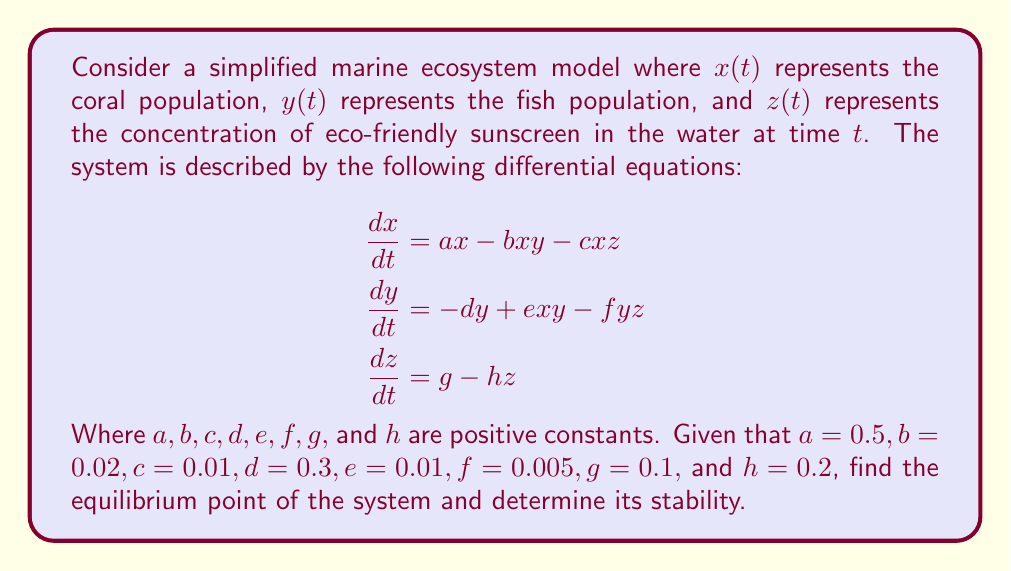Help me with this question. To solve this problem, we'll follow these steps:

1) Find the equilibrium point by setting all derivatives to zero and solving the resulting system of equations.

2) Compute the Jacobian matrix at the equilibrium point.

3) Evaluate the eigenvalues of the Jacobian to determine stability.

Step 1: Finding the equilibrium point

Set all derivatives to zero:

$$\begin{aligned}
0 &= 0.5x - 0.02xy - 0.01xz \\
0 &= -0.3y + 0.01xy - 0.005yz \\
0 &= 0.1 - 0.2z
\end{aligned}$$

From the third equation:
$z = 0.5$

Substituting this into the first two equations:

$$\begin{aligned}
0 &= 0.5x - 0.02xy - 0.005x \\
0 &= -0.3y + 0.01xy - 0.0025y
\end{aligned}$$

Simplifying:

$$\begin{aligned}
0 &= 0.495x - 0.02xy \\
0 &= y(0.01x - 0.3025)
\end{aligned}$$

From the second equation, either $y = 0$ or $x = 30.25$. If $y = 0$, then $x = 0$ from the first equation. If $x = 30.25$, then $y = 24.75$ from the first equation.

Therefore, the equilibrium point is $(x, y, z) = (30.25, 24.75, 0.5)$.

Step 2: Computing the Jacobian matrix

The Jacobian matrix is:

$$J = \begin{bmatrix}
0.5 - 0.02y - 0.01z & -0.02x & -0.01x \\
0.01y & -0.3 + 0.01x - 0.005z & -0.005y \\
0 & 0 & -0.2
\end{bmatrix}$$

At the equilibrium point:

$$J = \begin{bmatrix}
0 & -0.605 & -0.3025 \\
0.2475 & 0 & -0.12375 \\
0 & 0 & -0.2
\end{bmatrix}$$

Step 3: Evaluating eigenvalues

The characteristic equation is:

$$\det(J - \lambda I) = -\lambda^3 - 0.2\lambda^2 + 0.14953125\lambda + 0.02995625 = 0$$

Using the Routh-Hurwitz criterion, we can determine that all roots have negative real parts if and only if all coefficients are positive and $0.2 \cdot 0.14953125 > 0.02995625$, which is true.

Therefore, the equilibrium point is asymptotically stable.
Answer: The system has a stable equilibrium point at $(30.25, 24.75, 0.5)$. 